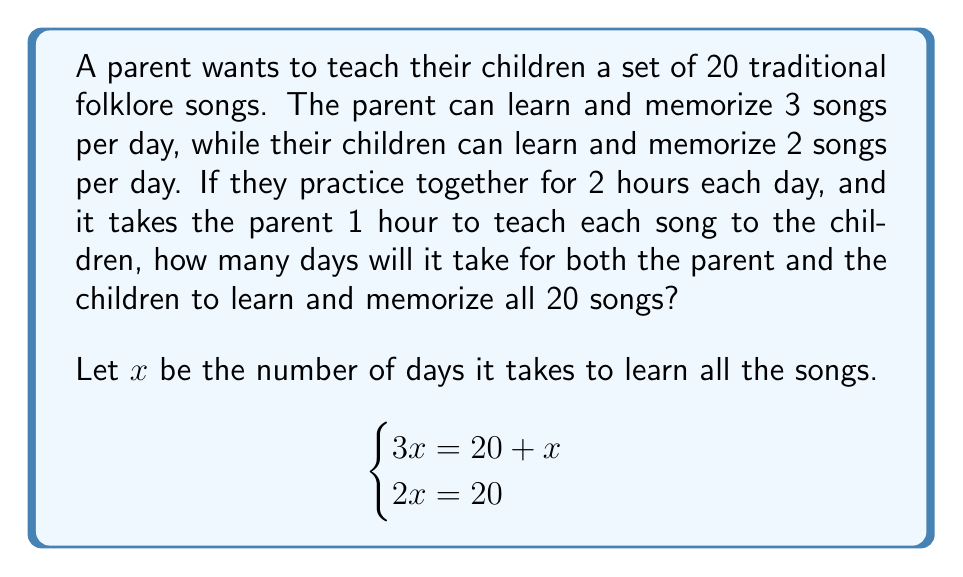Could you help me with this problem? Let's solve this system of equations step by step:

1) From the second equation, we can directly solve for $x$:
   $2x = 20$
   $x = 10$

2) Now, let's verify if this solution satisfies the first equation:
   $3x = 20 + x$
   $3(10) = 20 + 10$
   $30 = 30$

3) The solution $x = 10$ satisfies both equations, so it is the correct answer.

4) Interpretation of the solution:
   - It takes the children 10 days to learn all 20 songs (2 songs per day for 10 days)
   - The parent learns 3 songs per day for 10 days, which is 30 songs
   - However, the parent spends 1 hour each day teaching the children, so they can only learn 1 additional song per day
   - Over 10 days, the parent learns the 20 songs plus 10 additional songs

Therefore, it takes 10 days for both the parent and the children to learn and memorize all 20 songs.
Answer: 10 days 